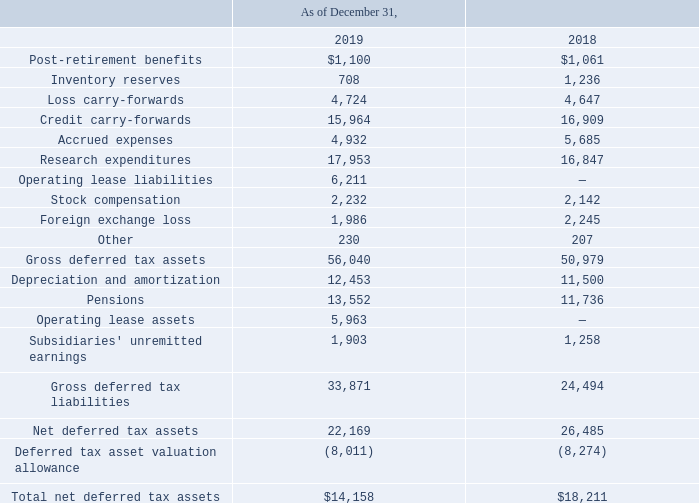NOTES TO CONSOLIDATED FINANCIAL STATEMENTS (in thousands, except for share and per share data)
NOTE 18 — Income Taxes
Significant components of our deferred tax assets and liabilities are as follows:
Which years does the table provide information for significant components of the company's deferred tax assets and liabilities? 2019, 2018. What were the inventory reserves in 2019?
Answer scale should be: thousand. 708. What was the Stock compensation in 2018?
Answer scale should be: thousand. 2,142. Which years did Depreciation and amortization exceed $10,000 thousand? (2019:12,453),(2018:11,500)
Answer: 2019, 2018. What was the change in Research expenditures between 2018 and 2019?
Answer scale should be: thousand. 17,953-16,847
Answer: 1106. What was the percentage change in the Gross deferred tax assets between 2018 and 2019?
Answer scale should be: percent. (56,040-50,979)/50,979
Answer: 9.93. 